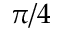<formula> <loc_0><loc_0><loc_500><loc_500>\pi / 4</formula> 